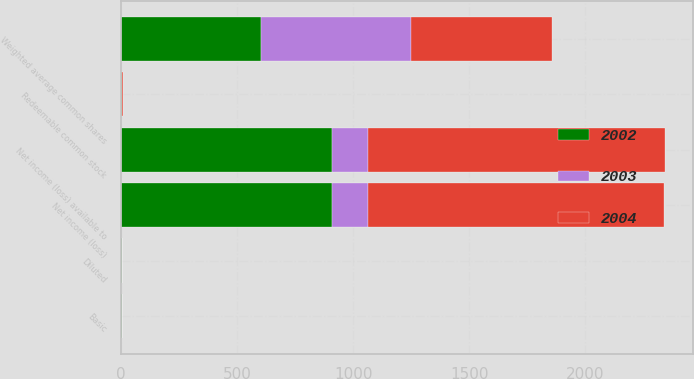<chart> <loc_0><loc_0><loc_500><loc_500><stacked_bar_chart><ecel><fcel>Net income (loss)<fcel>Redeemable common stock<fcel>Net income (loss) available to<fcel>Weighted average common shares<fcel>Basic<fcel>Diluted<nl><fcel>2003<fcel>157.2<fcel>0.5<fcel>156.3<fcel>645.7<fcel>0.24<fcel>0.24<nl><fcel>2004<fcel>1273.2<fcel>6.3<fcel>1279.5<fcel>607.5<fcel>2.11<fcel>2.11<nl><fcel>2002<fcel>907<fcel>2.1<fcel>909.1<fcel>601.5<fcel>1.51<fcel>1.51<nl></chart> 